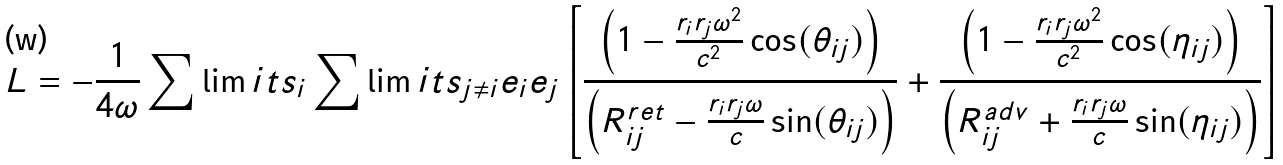<formula> <loc_0><loc_0><loc_500><loc_500>L = - \frac { 1 } { 4 \omega } \sum \lim i t s _ { i } \sum \lim i t s _ { j \neq i } e _ { i } e _ { j } \left [ \frac { \left ( 1 - \frac { r _ { i } r _ { j } \omega ^ { 2 } } { c ^ { 2 } } \cos ( \theta _ { i j } ) \right ) } { \left ( R ^ { r e t } _ { i j } - \frac { r _ { i } r _ { j } \omega } { c } \sin ( \theta _ { i j } ) \right ) } + \frac { \left ( 1 - \frac { r _ { i } r _ { j } \omega ^ { 2 } } { c ^ { 2 } } \cos ( \eta _ { i j } ) \right ) } { \left ( R ^ { a d v } _ { i j } + \frac { r _ { i } r _ { j } \omega } { c } \sin ( \eta _ { i j } ) \right ) } \right ]</formula> 